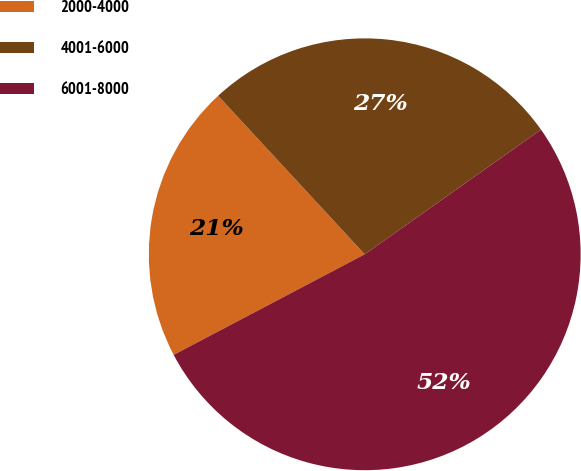<chart> <loc_0><loc_0><loc_500><loc_500><pie_chart><fcel>2000-4000<fcel>4001-6000<fcel>6001-8000<nl><fcel>20.83%<fcel>27.08%<fcel>52.08%<nl></chart> 